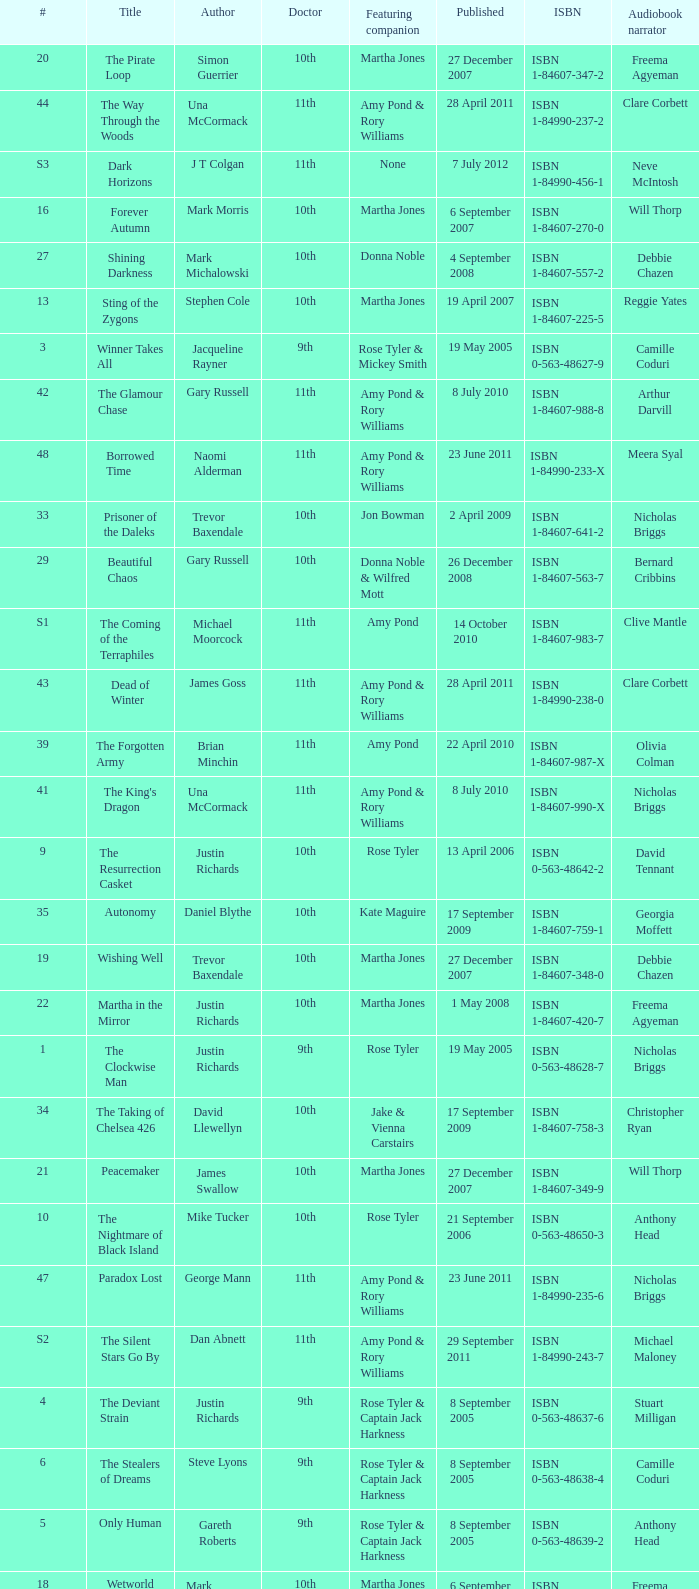What is the title of ISBN 1-84990-243-7? The Silent Stars Go By. 